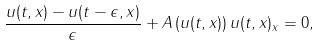<formula> <loc_0><loc_0><loc_500><loc_500>\frac { u ( t , x ) - u ( t - \epsilon , x ) } { \epsilon } + A \left ( u ( t , x ) \right ) u ( t , x ) _ { x } = 0 ,</formula> 